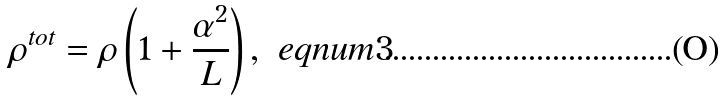<formula> <loc_0><loc_0><loc_500><loc_500>\rho ^ { t o t } = \rho \left ( 1 + \frac { \alpha ^ { 2 } } { L } \right ) , \ e q n u m { 3 }</formula> 